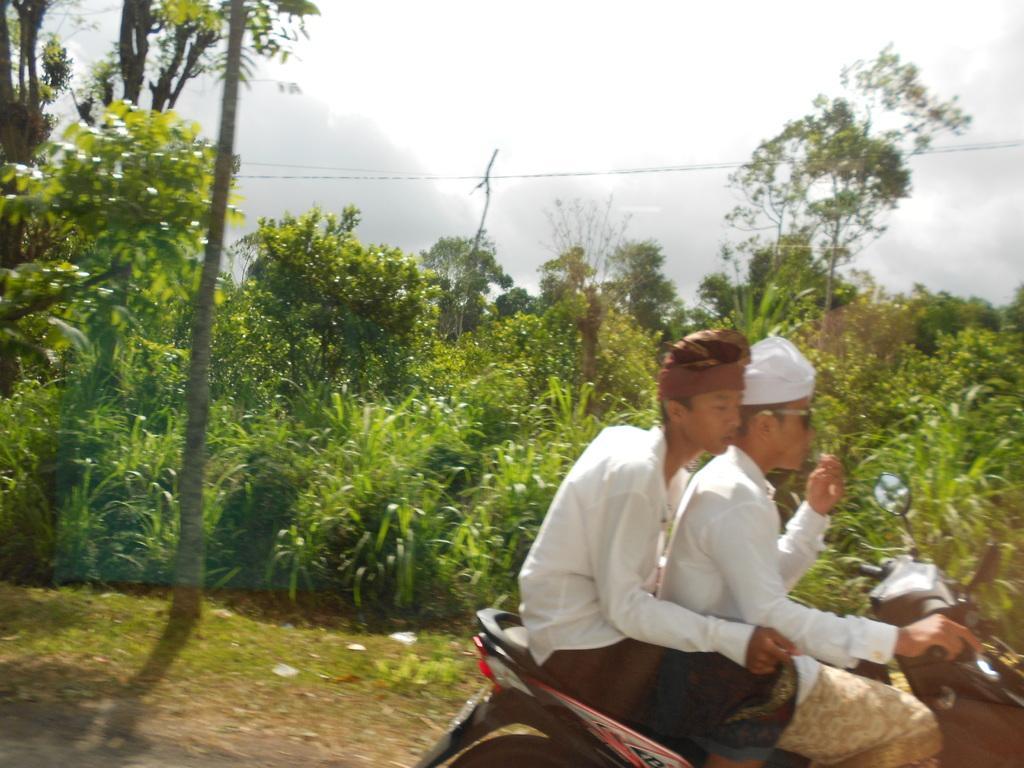Could you give a brief overview of what you see in this image? In the image we can see there are two men sitting on the scooty and behind there are plants and trees. 